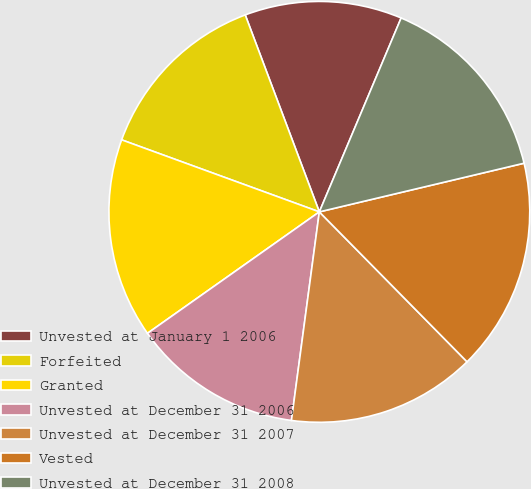Convert chart. <chart><loc_0><loc_0><loc_500><loc_500><pie_chart><fcel>Unvested at January 1 2006<fcel>Forfeited<fcel>Granted<fcel>Unvested at December 31 2006<fcel>Unvested at December 31 2007<fcel>Vested<fcel>Unvested at December 31 2008<nl><fcel>12.08%<fcel>13.71%<fcel>15.35%<fcel>13.09%<fcel>14.5%<fcel>16.33%<fcel>14.93%<nl></chart> 